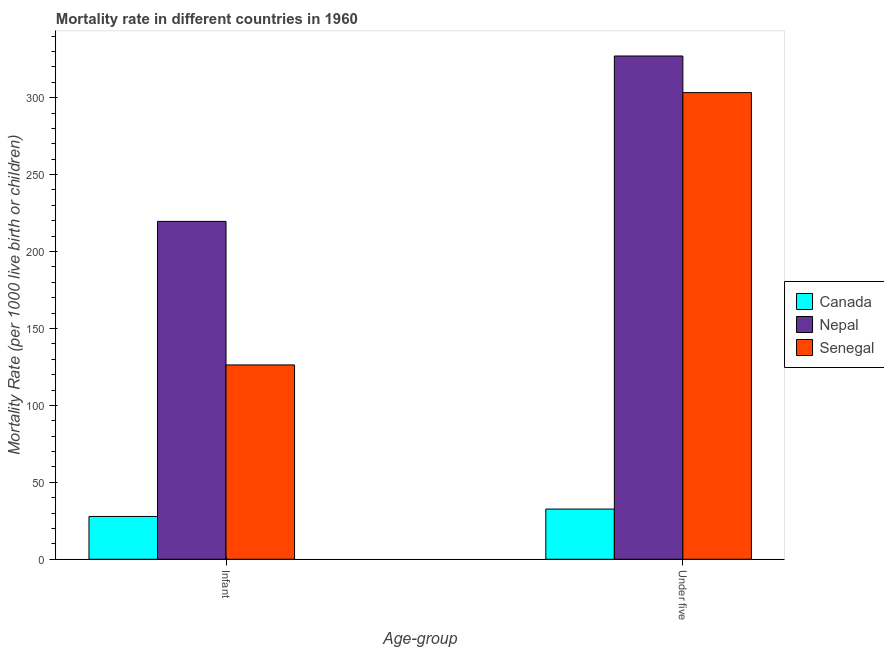How many groups of bars are there?
Give a very brief answer. 2. Are the number of bars per tick equal to the number of legend labels?
Your answer should be compact. Yes. Are the number of bars on each tick of the X-axis equal?
Offer a terse response. Yes. How many bars are there on the 1st tick from the left?
Offer a very short reply. 3. How many bars are there on the 2nd tick from the right?
Provide a succinct answer. 3. What is the label of the 2nd group of bars from the left?
Your response must be concise. Under five. What is the under-5 mortality rate in Senegal?
Give a very brief answer. 303.3. Across all countries, what is the maximum under-5 mortality rate?
Make the answer very short. 327.1. Across all countries, what is the minimum under-5 mortality rate?
Provide a succinct answer. 32.6. In which country was the under-5 mortality rate maximum?
Your answer should be compact. Nepal. In which country was the under-5 mortality rate minimum?
Your answer should be very brief. Canada. What is the total under-5 mortality rate in the graph?
Provide a succinct answer. 663. What is the difference between the infant mortality rate in Senegal and that in Canada?
Your response must be concise. 98.5. What is the difference between the under-5 mortality rate in Nepal and the infant mortality rate in Senegal?
Keep it short and to the point. 200.8. What is the average infant mortality rate per country?
Offer a terse response. 124.57. What is the difference between the infant mortality rate and under-5 mortality rate in Senegal?
Offer a very short reply. -177. What is the ratio of the infant mortality rate in Senegal to that in Canada?
Your answer should be compact. 4.54. In how many countries, is the under-5 mortality rate greater than the average under-5 mortality rate taken over all countries?
Keep it short and to the point. 2. What does the 2nd bar from the left in Under five represents?
Offer a very short reply. Nepal. How many countries are there in the graph?
Your answer should be very brief. 3. Are the values on the major ticks of Y-axis written in scientific E-notation?
Your answer should be very brief. No. Does the graph contain grids?
Offer a very short reply. No. Where does the legend appear in the graph?
Ensure brevity in your answer.  Center right. What is the title of the graph?
Make the answer very short. Mortality rate in different countries in 1960. Does "Turks and Caicos Islands" appear as one of the legend labels in the graph?
Your response must be concise. No. What is the label or title of the X-axis?
Ensure brevity in your answer.  Age-group. What is the label or title of the Y-axis?
Ensure brevity in your answer.  Mortality Rate (per 1000 live birth or children). What is the Mortality Rate (per 1000 live birth or children) of Canada in Infant?
Your answer should be compact. 27.8. What is the Mortality Rate (per 1000 live birth or children) of Nepal in Infant?
Give a very brief answer. 219.6. What is the Mortality Rate (per 1000 live birth or children) in Senegal in Infant?
Provide a short and direct response. 126.3. What is the Mortality Rate (per 1000 live birth or children) of Canada in Under five?
Ensure brevity in your answer.  32.6. What is the Mortality Rate (per 1000 live birth or children) in Nepal in Under five?
Keep it short and to the point. 327.1. What is the Mortality Rate (per 1000 live birth or children) of Senegal in Under five?
Your answer should be very brief. 303.3. Across all Age-group, what is the maximum Mortality Rate (per 1000 live birth or children) in Canada?
Offer a very short reply. 32.6. Across all Age-group, what is the maximum Mortality Rate (per 1000 live birth or children) in Nepal?
Give a very brief answer. 327.1. Across all Age-group, what is the maximum Mortality Rate (per 1000 live birth or children) in Senegal?
Provide a succinct answer. 303.3. Across all Age-group, what is the minimum Mortality Rate (per 1000 live birth or children) in Canada?
Ensure brevity in your answer.  27.8. Across all Age-group, what is the minimum Mortality Rate (per 1000 live birth or children) of Nepal?
Keep it short and to the point. 219.6. Across all Age-group, what is the minimum Mortality Rate (per 1000 live birth or children) in Senegal?
Offer a very short reply. 126.3. What is the total Mortality Rate (per 1000 live birth or children) of Canada in the graph?
Your response must be concise. 60.4. What is the total Mortality Rate (per 1000 live birth or children) of Nepal in the graph?
Ensure brevity in your answer.  546.7. What is the total Mortality Rate (per 1000 live birth or children) of Senegal in the graph?
Provide a succinct answer. 429.6. What is the difference between the Mortality Rate (per 1000 live birth or children) in Canada in Infant and that in Under five?
Your answer should be very brief. -4.8. What is the difference between the Mortality Rate (per 1000 live birth or children) of Nepal in Infant and that in Under five?
Offer a terse response. -107.5. What is the difference between the Mortality Rate (per 1000 live birth or children) of Senegal in Infant and that in Under five?
Your answer should be very brief. -177. What is the difference between the Mortality Rate (per 1000 live birth or children) of Canada in Infant and the Mortality Rate (per 1000 live birth or children) of Nepal in Under five?
Provide a succinct answer. -299.3. What is the difference between the Mortality Rate (per 1000 live birth or children) of Canada in Infant and the Mortality Rate (per 1000 live birth or children) of Senegal in Under five?
Offer a very short reply. -275.5. What is the difference between the Mortality Rate (per 1000 live birth or children) of Nepal in Infant and the Mortality Rate (per 1000 live birth or children) of Senegal in Under five?
Your response must be concise. -83.7. What is the average Mortality Rate (per 1000 live birth or children) in Canada per Age-group?
Your answer should be very brief. 30.2. What is the average Mortality Rate (per 1000 live birth or children) in Nepal per Age-group?
Make the answer very short. 273.35. What is the average Mortality Rate (per 1000 live birth or children) of Senegal per Age-group?
Your answer should be compact. 214.8. What is the difference between the Mortality Rate (per 1000 live birth or children) in Canada and Mortality Rate (per 1000 live birth or children) in Nepal in Infant?
Make the answer very short. -191.8. What is the difference between the Mortality Rate (per 1000 live birth or children) of Canada and Mortality Rate (per 1000 live birth or children) of Senegal in Infant?
Keep it short and to the point. -98.5. What is the difference between the Mortality Rate (per 1000 live birth or children) in Nepal and Mortality Rate (per 1000 live birth or children) in Senegal in Infant?
Make the answer very short. 93.3. What is the difference between the Mortality Rate (per 1000 live birth or children) of Canada and Mortality Rate (per 1000 live birth or children) of Nepal in Under five?
Ensure brevity in your answer.  -294.5. What is the difference between the Mortality Rate (per 1000 live birth or children) of Canada and Mortality Rate (per 1000 live birth or children) of Senegal in Under five?
Provide a short and direct response. -270.7. What is the difference between the Mortality Rate (per 1000 live birth or children) in Nepal and Mortality Rate (per 1000 live birth or children) in Senegal in Under five?
Offer a terse response. 23.8. What is the ratio of the Mortality Rate (per 1000 live birth or children) in Canada in Infant to that in Under five?
Make the answer very short. 0.85. What is the ratio of the Mortality Rate (per 1000 live birth or children) in Nepal in Infant to that in Under five?
Keep it short and to the point. 0.67. What is the ratio of the Mortality Rate (per 1000 live birth or children) of Senegal in Infant to that in Under five?
Your answer should be very brief. 0.42. What is the difference between the highest and the second highest Mortality Rate (per 1000 live birth or children) of Canada?
Your answer should be compact. 4.8. What is the difference between the highest and the second highest Mortality Rate (per 1000 live birth or children) of Nepal?
Offer a terse response. 107.5. What is the difference between the highest and the second highest Mortality Rate (per 1000 live birth or children) of Senegal?
Give a very brief answer. 177. What is the difference between the highest and the lowest Mortality Rate (per 1000 live birth or children) in Canada?
Your answer should be very brief. 4.8. What is the difference between the highest and the lowest Mortality Rate (per 1000 live birth or children) of Nepal?
Make the answer very short. 107.5. What is the difference between the highest and the lowest Mortality Rate (per 1000 live birth or children) in Senegal?
Provide a succinct answer. 177. 